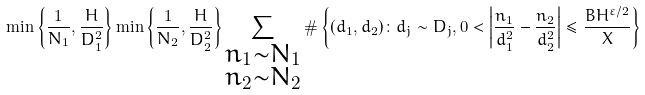Convert formula to latex. <formula><loc_0><loc_0><loc_500><loc_500>\min \left \{ \frac { 1 } { N _ { 1 } } , \frac { H } { D _ { 1 } ^ { 2 } } \right \} \min \left \{ \frac { 1 } { N _ { 2 } } , \frac { H } { D _ { 2 } ^ { 2 } } \right \} \sum _ { \substack { n _ { 1 } \sim N _ { 1 } \\ n _ { 2 } \sim N _ { 2 } } } \# \left \{ ( d _ { 1 } , d _ { 2 } ) \colon d _ { j } \sim D _ { j } , 0 < \left | \frac { n _ { 1 } } { d _ { 1 } ^ { 2 } } - \frac { n _ { 2 } } { d _ { 2 } ^ { 2 } } \right | \leq \frac { B H ^ { \varepsilon / 2 } } { X } \right \}</formula> 